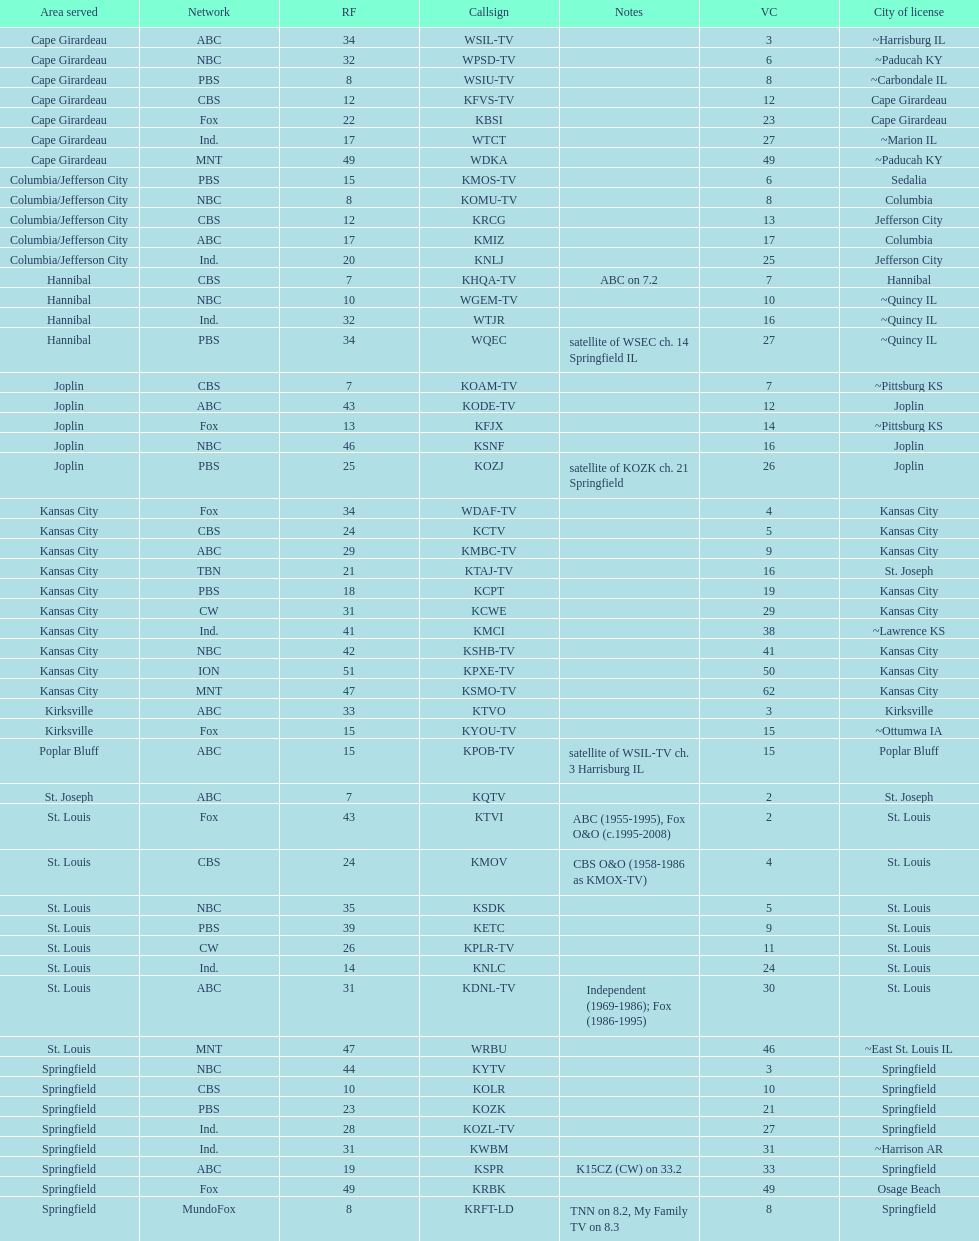Kode-tv and wsil-tv both are a part of which network? ABC. 